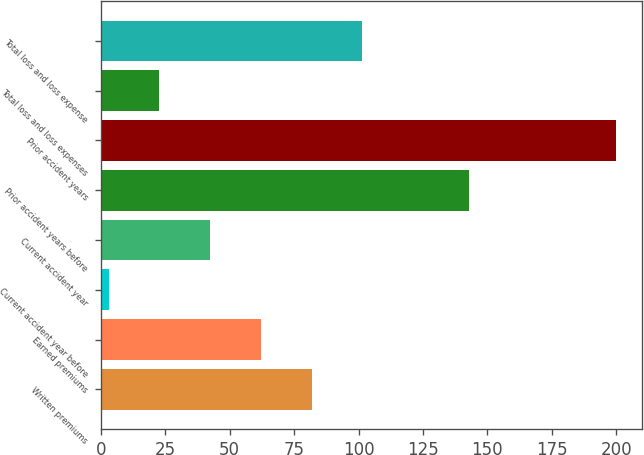Convert chart to OTSL. <chart><loc_0><loc_0><loc_500><loc_500><bar_chart><fcel>Written premiums<fcel>Earned premiums<fcel>Current accident year before<fcel>Current accident year<fcel>Prior accident years before<fcel>Prior accident years<fcel>Total loss and loss expenses<fcel>Total loss and loss expense<nl><fcel>81.8<fcel>62.1<fcel>3<fcel>42.4<fcel>143<fcel>200<fcel>22.7<fcel>101.5<nl></chart> 